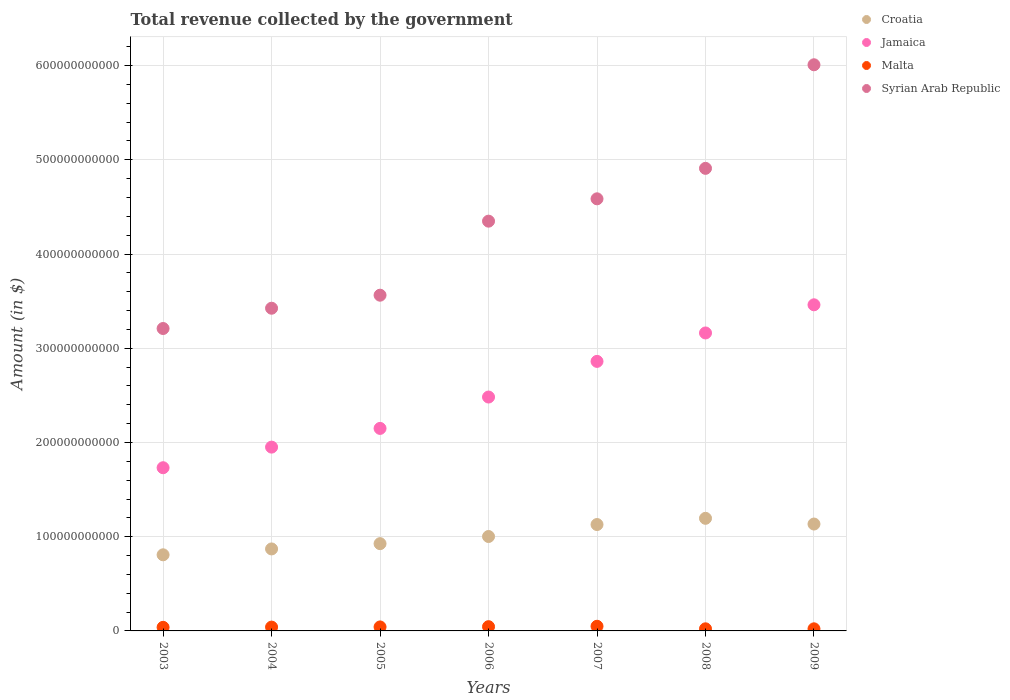How many different coloured dotlines are there?
Your answer should be compact. 4. What is the total revenue collected by the government in Syrian Arab Republic in 2005?
Keep it short and to the point. 3.56e+11. Across all years, what is the maximum total revenue collected by the government in Malta?
Your answer should be compact. 4.93e+09. Across all years, what is the minimum total revenue collected by the government in Syrian Arab Republic?
Your answer should be very brief. 3.21e+11. In which year was the total revenue collected by the government in Jamaica maximum?
Make the answer very short. 2009. In which year was the total revenue collected by the government in Croatia minimum?
Give a very brief answer. 2003. What is the total total revenue collected by the government in Malta in the graph?
Offer a terse response. 2.60e+1. What is the difference between the total revenue collected by the government in Malta in 2003 and that in 2007?
Offer a very short reply. -1.13e+09. What is the difference between the total revenue collected by the government in Syrian Arab Republic in 2003 and the total revenue collected by the government in Jamaica in 2009?
Offer a terse response. -2.52e+1. What is the average total revenue collected by the government in Syrian Arab Republic per year?
Keep it short and to the point. 4.29e+11. In the year 2005, what is the difference between the total revenue collected by the government in Croatia and total revenue collected by the government in Jamaica?
Provide a short and direct response. -1.22e+11. What is the ratio of the total revenue collected by the government in Malta in 2003 to that in 2007?
Your answer should be very brief. 0.77. Is the difference between the total revenue collected by the government in Croatia in 2007 and 2008 greater than the difference between the total revenue collected by the government in Jamaica in 2007 and 2008?
Give a very brief answer. Yes. What is the difference between the highest and the second highest total revenue collected by the government in Syrian Arab Republic?
Give a very brief answer. 1.10e+11. What is the difference between the highest and the lowest total revenue collected by the government in Syrian Arab Republic?
Provide a short and direct response. 2.80e+11. Does the total revenue collected by the government in Syrian Arab Republic monotonically increase over the years?
Your answer should be very brief. Yes. Is the total revenue collected by the government in Jamaica strictly greater than the total revenue collected by the government in Croatia over the years?
Provide a succinct answer. Yes. Is the total revenue collected by the government in Syrian Arab Republic strictly less than the total revenue collected by the government in Jamaica over the years?
Provide a succinct answer. No. How many dotlines are there?
Your answer should be compact. 4. What is the difference between two consecutive major ticks on the Y-axis?
Your response must be concise. 1.00e+11. Does the graph contain any zero values?
Your response must be concise. No. Does the graph contain grids?
Your answer should be compact. Yes. How many legend labels are there?
Your answer should be compact. 4. What is the title of the graph?
Your answer should be compact. Total revenue collected by the government. Does "Qatar" appear as one of the legend labels in the graph?
Make the answer very short. No. What is the label or title of the Y-axis?
Your response must be concise. Amount (in $). What is the Amount (in $) in Croatia in 2003?
Provide a succinct answer. 8.08e+1. What is the Amount (in $) of Jamaica in 2003?
Provide a short and direct response. 1.73e+11. What is the Amount (in $) in Malta in 2003?
Keep it short and to the point. 3.81e+09. What is the Amount (in $) in Syrian Arab Republic in 2003?
Offer a very short reply. 3.21e+11. What is the Amount (in $) of Croatia in 2004?
Ensure brevity in your answer.  8.70e+1. What is the Amount (in $) in Jamaica in 2004?
Provide a succinct answer. 1.95e+11. What is the Amount (in $) of Malta in 2004?
Provide a short and direct response. 4.05e+09. What is the Amount (in $) in Syrian Arab Republic in 2004?
Offer a very short reply. 3.42e+11. What is the Amount (in $) of Croatia in 2005?
Make the answer very short. 9.26e+1. What is the Amount (in $) in Jamaica in 2005?
Ensure brevity in your answer.  2.15e+11. What is the Amount (in $) in Malta in 2005?
Your response must be concise. 4.23e+09. What is the Amount (in $) in Syrian Arab Republic in 2005?
Offer a terse response. 3.56e+11. What is the Amount (in $) of Croatia in 2006?
Your answer should be very brief. 1.00e+11. What is the Amount (in $) of Jamaica in 2006?
Provide a short and direct response. 2.48e+11. What is the Amount (in $) in Malta in 2006?
Your answer should be compact. 4.51e+09. What is the Amount (in $) in Syrian Arab Republic in 2006?
Your response must be concise. 4.35e+11. What is the Amount (in $) in Croatia in 2007?
Keep it short and to the point. 1.13e+11. What is the Amount (in $) of Jamaica in 2007?
Give a very brief answer. 2.86e+11. What is the Amount (in $) of Malta in 2007?
Make the answer very short. 4.93e+09. What is the Amount (in $) in Syrian Arab Republic in 2007?
Provide a short and direct response. 4.59e+11. What is the Amount (in $) of Croatia in 2008?
Offer a terse response. 1.19e+11. What is the Amount (in $) of Jamaica in 2008?
Give a very brief answer. 3.16e+11. What is the Amount (in $) in Malta in 2008?
Ensure brevity in your answer.  2.24e+09. What is the Amount (in $) in Syrian Arab Republic in 2008?
Your response must be concise. 4.91e+11. What is the Amount (in $) in Croatia in 2009?
Keep it short and to the point. 1.13e+11. What is the Amount (in $) of Jamaica in 2009?
Provide a short and direct response. 3.46e+11. What is the Amount (in $) of Malta in 2009?
Your response must be concise. 2.24e+09. What is the Amount (in $) in Syrian Arab Republic in 2009?
Provide a short and direct response. 6.01e+11. Across all years, what is the maximum Amount (in $) of Croatia?
Provide a succinct answer. 1.19e+11. Across all years, what is the maximum Amount (in $) in Jamaica?
Offer a very short reply. 3.46e+11. Across all years, what is the maximum Amount (in $) of Malta?
Offer a terse response. 4.93e+09. Across all years, what is the maximum Amount (in $) of Syrian Arab Republic?
Your answer should be compact. 6.01e+11. Across all years, what is the minimum Amount (in $) in Croatia?
Keep it short and to the point. 8.08e+1. Across all years, what is the minimum Amount (in $) of Jamaica?
Ensure brevity in your answer.  1.73e+11. Across all years, what is the minimum Amount (in $) in Malta?
Your response must be concise. 2.24e+09. Across all years, what is the minimum Amount (in $) of Syrian Arab Republic?
Offer a very short reply. 3.21e+11. What is the total Amount (in $) in Croatia in the graph?
Ensure brevity in your answer.  7.06e+11. What is the total Amount (in $) in Jamaica in the graph?
Provide a succinct answer. 1.78e+12. What is the total Amount (in $) of Malta in the graph?
Your answer should be very brief. 2.60e+1. What is the total Amount (in $) in Syrian Arab Republic in the graph?
Your response must be concise. 3.00e+12. What is the difference between the Amount (in $) in Croatia in 2003 and that in 2004?
Your answer should be compact. -6.23e+09. What is the difference between the Amount (in $) in Jamaica in 2003 and that in 2004?
Your answer should be compact. -2.19e+1. What is the difference between the Amount (in $) in Malta in 2003 and that in 2004?
Make the answer very short. -2.43e+08. What is the difference between the Amount (in $) of Syrian Arab Republic in 2003 and that in 2004?
Your response must be concise. -2.15e+1. What is the difference between the Amount (in $) of Croatia in 2003 and that in 2005?
Keep it short and to the point. -1.18e+1. What is the difference between the Amount (in $) in Jamaica in 2003 and that in 2005?
Make the answer very short. -4.17e+1. What is the difference between the Amount (in $) in Malta in 2003 and that in 2005?
Offer a very short reply. -4.25e+08. What is the difference between the Amount (in $) in Syrian Arab Republic in 2003 and that in 2005?
Offer a very short reply. -3.54e+1. What is the difference between the Amount (in $) in Croatia in 2003 and that in 2006?
Ensure brevity in your answer.  -1.94e+1. What is the difference between the Amount (in $) in Jamaica in 2003 and that in 2006?
Offer a very short reply. -7.50e+1. What is the difference between the Amount (in $) of Malta in 2003 and that in 2006?
Make the answer very short. -7.00e+08. What is the difference between the Amount (in $) in Syrian Arab Republic in 2003 and that in 2006?
Provide a short and direct response. -1.14e+11. What is the difference between the Amount (in $) in Croatia in 2003 and that in 2007?
Offer a terse response. -3.21e+1. What is the difference between the Amount (in $) in Jamaica in 2003 and that in 2007?
Ensure brevity in your answer.  -1.13e+11. What is the difference between the Amount (in $) in Malta in 2003 and that in 2007?
Your response must be concise. -1.13e+09. What is the difference between the Amount (in $) of Syrian Arab Republic in 2003 and that in 2007?
Your answer should be very brief. -1.38e+11. What is the difference between the Amount (in $) of Croatia in 2003 and that in 2008?
Provide a succinct answer. -3.87e+1. What is the difference between the Amount (in $) in Jamaica in 2003 and that in 2008?
Provide a short and direct response. -1.43e+11. What is the difference between the Amount (in $) in Malta in 2003 and that in 2008?
Your answer should be very brief. 1.57e+09. What is the difference between the Amount (in $) of Syrian Arab Republic in 2003 and that in 2008?
Make the answer very short. -1.70e+11. What is the difference between the Amount (in $) in Croatia in 2003 and that in 2009?
Make the answer very short. -3.27e+1. What is the difference between the Amount (in $) in Jamaica in 2003 and that in 2009?
Offer a terse response. -1.73e+11. What is the difference between the Amount (in $) of Malta in 2003 and that in 2009?
Ensure brevity in your answer.  1.57e+09. What is the difference between the Amount (in $) in Syrian Arab Republic in 2003 and that in 2009?
Give a very brief answer. -2.80e+11. What is the difference between the Amount (in $) in Croatia in 2004 and that in 2005?
Give a very brief answer. -5.61e+09. What is the difference between the Amount (in $) in Jamaica in 2004 and that in 2005?
Give a very brief answer. -1.99e+1. What is the difference between the Amount (in $) of Malta in 2004 and that in 2005?
Your answer should be compact. -1.83e+08. What is the difference between the Amount (in $) in Syrian Arab Republic in 2004 and that in 2005?
Your answer should be compact. -1.38e+1. What is the difference between the Amount (in $) of Croatia in 2004 and that in 2006?
Keep it short and to the point. -1.32e+1. What is the difference between the Amount (in $) of Jamaica in 2004 and that in 2006?
Ensure brevity in your answer.  -5.32e+1. What is the difference between the Amount (in $) of Malta in 2004 and that in 2006?
Provide a succinct answer. -4.58e+08. What is the difference between the Amount (in $) in Syrian Arab Republic in 2004 and that in 2006?
Your answer should be very brief. -9.24e+1. What is the difference between the Amount (in $) of Croatia in 2004 and that in 2007?
Make the answer very short. -2.59e+1. What is the difference between the Amount (in $) of Jamaica in 2004 and that in 2007?
Make the answer very short. -9.10e+1. What is the difference between the Amount (in $) of Malta in 2004 and that in 2007?
Provide a succinct answer. -8.84e+08. What is the difference between the Amount (in $) in Syrian Arab Republic in 2004 and that in 2007?
Provide a succinct answer. -1.16e+11. What is the difference between the Amount (in $) of Croatia in 2004 and that in 2008?
Keep it short and to the point. -3.25e+1. What is the difference between the Amount (in $) of Jamaica in 2004 and that in 2008?
Your answer should be compact. -1.21e+11. What is the difference between the Amount (in $) in Malta in 2004 and that in 2008?
Offer a very short reply. 1.81e+09. What is the difference between the Amount (in $) of Syrian Arab Republic in 2004 and that in 2008?
Give a very brief answer. -1.48e+11. What is the difference between the Amount (in $) of Croatia in 2004 and that in 2009?
Your response must be concise. -2.64e+1. What is the difference between the Amount (in $) of Jamaica in 2004 and that in 2009?
Your response must be concise. -1.51e+11. What is the difference between the Amount (in $) in Malta in 2004 and that in 2009?
Keep it short and to the point. 1.81e+09. What is the difference between the Amount (in $) of Syrian Arab Republic in 2004 and that in 2009?
Offer a very short reply. -2.58e+11. What is the difference between the Amount (in $) of Croatia in 2005 and that in 2006?
Keep it short and to the point. -7.58e+09. What is the difference between the Amount (in $) of Jamaica in 2005 and that in 2006?
Give a very brief answer. -3.33e+1. What is the difference between the Amount (in $) of Malta in 2005 and that in 2006?
Give a very brief answer. -2.75e+08. What is the difference between the Amount (in $) of Syrian Arab Republic in 2005 and that in 2006?
Your answer should be very brief. -7.86e+1. What is the difference between the Amount (in $) of Croatia in 2005 and that in 2007?
Offer a terse response. -2.03e+1. What is the difference between the Amount (in $) of Jamaica in 2005 and that in 2007?
Keep it short and to the point. -7.11e+1. What is the difference between the Amount (in $) in Malta in 2005 and that in 2007?
Your answer should be compact. -7.01e+08. What is the difference between the Amount (in $) in Syrian Arab Republic in 2005 and that in 2007?
Ensure brevity in your answer.  -1.02e+11. What is the difference between the Amount (in $) of Croatia in 2005 and that in 2008?
Give a very brief answer. -2.69e+1. What is the difference between the Amount (in $) in Jamaica in 2005 and that in 2008?
Make the answer very short. -1.01e+11. What is the difference between the Amount (in $) of Malta in 2005 and that in 2008?
Your answer should be compact. 1.99e+09. What is the difference between the Amount (in $) of Syrian Arab Republic in 2005 and that in 2008?
Offer a terse response. -1.35e+11. What is the difference between the Amount (in $) of Croatia in 2005 and that in 2009?
Ensure brevity in your answer.  -2.08e+1. What is the difference between the Amount (in $) of Jamaica in 2005 and that in 2009?
Give a very brief answer. -1.31e+11. What is the difference between the Amount (in $) in Malta in 2005 and that in 2009?
Provide a succinct answer. 2.00e+09. What is the difference between the Amount (in $) of Syrian Arab Republic in 2005 and that in 2009?
Your answer should be compact. -2.45e+11. What is the difference between the Amount (in $) in Croatia in 2006 and that in 2007?
Make the answer very short. -1.27e+1. What is the difference between the Amount (in $) in Jamaica in 2006 and that in 2007?
Give a very brief answer. -3.78e+1. What is the difference between the Amount (in $) in Malta in 2006 and that in 2007?
Make the answer very short. -4.26e+08. What is the difference between the Amount (in $) of Syrian Arab Republic in 2006 and that in 2007?
Provide a succinct answer. -2.37e+1. What is the difference between the Amount (in $) of Croatia in 2006 and that in 2008?
Your answer should be very brief. -1.93e+1. What is the difference between the Amount (in $) in Jamaica in 2006 and that in 2008?
Offer a very short reply. -6.80e+1. What is the difference between the Amount (in $) of Malta in 2006 and that in 2008?
Ensure brevity in your answer.  2.27e+09. What is the difference between the Amount (in $) in Syrian Arab Republic in 2006 and that in 2008?
Offer a terse response. -5.60e+1. What is the difference between the Amount (in $) of Croatia in 2006 and that in 2009?
Provide a succinct answer. -1.32e+1. What is the difference between the Amount (in $) in Jamaica in 2006 and that in 2009?
Your response must be concise. -9.79e+1. What is the difference between the Amount (in $) of Malta in 2006 and that in 2009?
Make the answer very short. 2.27e+09. What is the difference between the Amount (in $) in Syrian Arab Republic in 2006 and that in 2009?
Your answer should be very brief. -1.66e+11. What is the difference between the Amount (in $) of Croatia in 2007 and that in 2008?
Your answer should be very brief. -6.59e+09. What is the difference between the Amount (in $) in Jamaica in 2007 and that in 2008?
Offer a very short reply. -3.02e+1. What is the difference between the Amount (in $) of Malta in 2007 and that in 2008?
Your answer should be compact. 2.69e+09. What is the difference between the Amount (in $) of Syrian Arab Republic in 2007 and that in 2008?
Provide a succinct answer. -3.23e+1. What is the difference between the Amount (in $) in Croatia in 2007 and that in 2009?
Ensure brevity in your answer.  -5.30e+08. What is the difference between the Amount (in $) in Jamaica in 2007 and that in 2009?
Ensure brevity in your answer.  -6.01e+1. What is the difference between the Amount (in $) of Malta in 2007 and that in 2009?
Make the answer very short. 2.70e+09. What is the difference between the Amount (in $) of Syrian Arab Republic in 2007 and that in 2009?
Your answer should be very brief. -1.42e+11. What is the difference between the Amount (in $) of Croatia in 2008 and that in 2009?
Provide a short and direct response. 6.06e+09. What is the difference between the Amount (in $) in Jamaica in 2008 and that in 2009?
Your answer should be compact. -2.99e+1. What is the difference between the Amount (in $) in Malta in 2008 and that in 2009?
Your answer should be compact. 6.17e+06. What is the difference between the Amount (in $) in Syrian Arab Republic in 2008 and that in 2009?
Your answer should be very brief. -1.10e+11. What is the difference between the Amount (in $) of Croatia in 2003 and the Amount (in $) of Jamaica in 2004?
Give a very brief answer. -1.14e+11. What is the difference between the Amount (in $) in Croatia in 2003 and the Amount (in $) in Malta in 2004?
Your answer should be very brief. 7.67e+1. What is the difference between the Amount (in $) in Croatia in 2003 and the Amount (in $) in Syrian Arab Republic in 2004?
Make the answer very short. -2.62e+11. What is the difference between the Amount (in $) in Jamaica in 2003 and the Amount (in $) in Malta in 2004?
Ensure brevity in your answer.  1.69e+11. What is the difference between the Amount (in $) in Jamaica in 2003 and the Amount (in $) in Syrian Arab Republic in 2004?
Offer a very short reply. -1.69e+11. What is the difference between the Amount (in $) in Malta in 2003 and the Amount (in $) in Syrian Arab Republic in 2004?
Provide a short and direct response. -3.39e+11. What is the difference between the Amount (in $) of Croatia in 2003 and the Amount (in $) of Jamaica in 2005?
Your answer should be very brief. -1.34e+11. What is the difference between the Amount (in $) in Croatia in 2003 and the Amount (in $) in Malta in 2005?
Keep it short and to the point. 7.65e+1. What is the difference between the Amount (in $) of Croatia in 2003 and the Amount (in $) of Syrian Arab Republic in 2005?
Your response must be concise. -2.76e+11. What is the difference between the Amount (in $) of Jamaica in 2003 and the Amount (in $) of Malta in 2005?
Provide a short and direct response. 1.69e+11. What is the difference between the Amount (in $) of Jamaica in 2003 and the Amount (in $) of Syrian Arab Republic in 2005?
Give a very brief answer. -1.83e+11. What is the difference between the Amount (in $) of Malta in 2003 and the Amount (in $) of Syrian Arab Republic in 2005?
Your response must be concise. -3.52e+11. What is the difference between the Amount (in $) of Croatia in 2003 and the Amount (in $) of Jamaica in 2006?
Provide a short and direct response. -1.67e+11. What is the difference between the Amount (in $) in Croatia in 2003 and the Amount (in $) in Malta in 2006?
Your response must be concise. 7.63e+1. What is the difference between the Amount (in $) in Croatia in 2003 and the Amount (in $) in Syrian Arab Republic in 2006?
Offer a terse response. -3.54e+11. What is the difference between the Amount (in $) of Jamaica in 2003 and the Amount (in $) of Malta in 2006?
Make the answer very short. 1.69e+11. What is the difference between the Amount (in $) in Jamaica in 2003 and the Amount (in $) in Syrian Arab Republic in 2006?
Your answer should be compact. -2.62e+11. What is the difference between the Amount (in $) of Malta in 2003 and the Amount (in $) of Syrian Arab Republic in 2006?
Offer a very short reply. -4.31e+11. What is the difference between the Amount (in $) of Croatia in 2003 and the Amount (in $) of Jamaica in 2007?
Offer a very short reply. -2.05e+11. What is the difference between the Amount (in $) in Croatia in 2003 and the Amount (in $) in Malta in 2007?
Your answer should be compact. 7.58e+1. What is the difference between the Amount (in $) of Croatia in 2003 and the Amount (in $) of Syrian Arab Republic in 2007?
Offer a very short reply. -3.78e+11. What is the difference between the Amount (in $) in Jamaica in 2003 and the Amount (in $) in Malta in 2007?
Offer a terse response. 1.68e+11. What is the difference between the Amount (in $) of Jamaica in 2003 and the Amount (in $) of Syrian Arab Republic in 2007?
Ensure brevity in your answer.  -2.85e+11. What is the difference between the Amount (in $) of Malta in 2003 and the Amount (in $) of Syrian Arab Republic in 2007?
Keep it short and to the point. -4.55e+11. What is the difference between the Amount (in $) of Croatia in 2003 and the Amount (in $) of Jamaica in 2008?
Your answer should be compact. -2.35e+11. What is the difference between the Amount (in $) in Croatia in 2003 and the Amount (in $) in Malta in 2008?
Your answer should be very brief. 7.85e+1. What is the difference between the Amount (in $) of Croatia in 2003 and the Amount (in $) of Syrian Arab Republic in 2008?
Ensure brevity in your answer.  -4.10e+11. What is the difference between the Amount (in $) of Jamaica in 2003 and the Amount (in $) of Malta in 2008?
Your answer should be very brief. 1.71e+11. What is the difference between the Amount (in $) in Jamaica in 2003 and the Amount (in $) in Syrian Arab Republic in 2008?
Your answer should be compact. -3.18e+11. What is the difference between the Amount (in $) in Malta in 2003 and the Amount (in $) in Syrian Arab Republic in 2008?
Ensure brevity in your answer.  -4.87e+11. What is the difference between the Amount (in $) in Croatia in 2003 and the Amount (in $) in Jamaica in 2009?
Provide a succinct answer. -2.65e+11. What is the difference between the Amount (in $) of Croatia in 2003 and the Amount (in $) of Malta in 2009?
Offer a very short reply. 7.85e+1. What is the difference between the Amount (in $) of Croatia in 2003 and the Amount (in $) of Syrian Arab Republic in 2009?
Keep it short and to the point. -5.20e+11. What is the difference between the Amount (in $) in Jamaica in 2003 and the Amount (in $) in Malta in 2009?
Your answer should be compact. 1.71e+11. What is the difference between the Amount (in $) in Jamaica in 2003 and the Amount (in $) in Syrian Arab Republic in 2009?
Your response must be concise. -4.28e+11. What is the difference between the Amount (in $) in Malta in 2003 and the Amount (in $) in Syrian Arab Republic in 2009?
Your answer should be compact. -5.97e+11. What is the difference between the Amount (in $) of Croatia in 2004 and the Amount (in $) of Jamaica in 2005?
Keep it short and to the point. -1.28e+11. What is the difference between the Amount (in $) in Croatia in 2004 and the Amount (in $) in Malta in 2005?
Give a very brief answer. 8.28e+1. What is the difference between the Amount (in $) of Croatia in 2004 and the Amount (in $) of Syrian Arab Republic in 2005?
Offer a terse response. -2.69e+11. What is the difference between the Amount (in $) in Jamaica in 2004 and the Amount (in $) in Malta in 2005?
Ensure brevity in your answer.  1.91e+11. What is the difference between the Amount (in $) in Jamaica in 2004 and the Amount (in $) in Syrian Arab Republic in 2005?
Provide a short and direct response. -1.61e+11. What is the difference between the Amount (in $) of Malta in 2004 and the Amount (in $) of Syrian Arab Republic in 2005?
Your answer should be compact. -3.52e+11. What is the difference between the Amount (in $) of Croatia in 2004 and the Amount (in $) of Jamaica in 2006?
Your answer should be very brief. -1.61e+11. What is the difference between the Amount (in $) in Croatia in 2004 and the Amount (in $) in Malta in 2006?
Make the answer very short. 8.25e+1. What is the difference between the Amount (in $) of Croatia in 2004 and the Amount (in $) of Syrian Arab Republic in 2006?
Make the answer very short. -3.48e+11. What is the difference between the Amount (in $) of Jamaica in 2004 and the Amount (in $) of Malta in 2006?
Your response must be concise. 1.91e+11. What is the difference between the Amount (in $) of Jamaica in 2004 and the Amount (in $) of Syrian Arab Republic in 2006?
Keep it short and to the point. -2.40e+11. What is the difference between the Amount (in $) in Malta in 2004 and the Amount (in $) in Syrian Arab Republic in 2006?
Provide a succinct answer. -4.31e+11. What is the difference between the Amount (in $) of Croatia in 2004 and the Amount (in $) of Jamaica in 2007?
Your answer should be compact. -1.99e+11. What is the difference between the Amount (in $) of Croatia in 2004 and the Amount (in $) of Malta in 2007?
Provide a succinct answer. 8.21e+1. What is the difference between the Amount (in $) of Croatia in 2004 and the Amount (in $) of Syrian Arab Republic in 2007?
Your response must be concise. -3.72e+11. What is the difference between the Amount (in $) in Jamaica in 2004 and the Amount (in $) in Malta in 2007?
Keep it short and to the point. 1.90e+11. What is the difference between the Amount (in $) of Jamaica in 2004 and the Amount (in $) of Syrian Arab Republic in 2007?
Offer a terse response. -2.64e+11. What is the difference between the Amount (in $) of Malta in 2004 and the Amount (in $) of Syrian Arab Republic in 2007?
Give a very brief answer. -4.55e+11. What is the difference between the Amount (in $) of Croatia in 2004 and the Amount (in $) of Jamaica in 2008?
Provide a short and direct response. -2.29e+11. What is the difference between the Amount (in $) of Croatia in 2004 and the Amount (in $) of Malta in 2008?
Ensure brevity in your answer.  8.48e+1. What is the difference between the Amount (in $) in Croatia in 2004 and the Amount (in $) in Syrian Arab Republic in 2008?
Offer a very short reply. -4.04e+11. What is the difference between the Amount (in $) of Jamaica in 2004 and the Amount (in $) of Malta in 2008?
Keep it short and to the point. 1.93e+11. What is the difference between the Amount (in $) in Jamaica in 2004 and the Amount (in $) in Syrian Arab Republic in 2008?
Make the answer very short. -2.96e+11. What is the difference between the Amount (in $) of Malta in 2004 and the Amount (in $) of Syrian Arab Republic in 2008?
Provide a short and direct response. -4.87e+11. What is the difference between the Amount (in $) in Croatia in 2004 and the Amount (in $) in Jamaica in 2009?
Provide a short and direct response. -2.59e+11. What is the difference between the Amount (in $) in Croatia in 2004 and the Amount (in $) in Malta in 2009?
Your answer should be very brief. 8.48e+1. What is the difference between the Amount (in $) of Croatia in 2004 and the Amount (in $) of Syrian Arab Republic in 2009?
Provide a succinct answer. -5.14e+11. What is the difference between the Amount (in $) in Jamaica in 2004 and the Amount (in $) in Malta in 2009?
Your answer should be very brief. 1.93e+11. What is the difference between the Amount (in $) of Jamaica in 2004 and the Amount (in $) of Syrian Arab Republic in 2009?
Ensure brevity in your answer.  -4.06e+11. What is the difference between the Amount (in $) in Malta in 2004 and the Amount (in $) in Syrian Arab Republic in 2009?
Make the answer very short. -5.97e+11. What is the difference between the Amount (in $) in Croatia in 2005 and the Amount (in $) in Jamaica in 2006?
Provide a succinct answer. -1.56e+11. What is the difference between the Amount (in $) in Croatia in 2005 and the Amount (in $) in Malta in 2006?
Offer a terse response. 8.81e+1. What is the difference between the Amount (in $) of Croatia in 2005 and the Amount (in $) of Syrian Arab Republic in 2006?
Provide a short and direct response. -3.42e+11. What is the difference between the Amount (in $) in Jamaica in 2005 and the Amount (in $) in Malta in 2006?
Offer a very short reply. 2.10e+11. What is the difference between the Amount (in $) in Jamaica in 2005 and the Amount (in $) in Syrian Arab Republic in 2006?
Give a very brief answer. -2.20e+11. What is the difference between the Amount (in $) in Malta in 2005 and the Amount (in $) in Syrian Arab Republic in 2006?
Make the answer very short. -4.31e+11. What is the difference between the Amount (in $) in Croatia in 2005 and the Amount (in $) in Jamaica in 2007?
Your response must be concise. -1.93e+11. What is the difference between the Amount (in $) in Croatia in 2005 and the Amount (in $) in Malta in 2007?
Make the answer very short. 8.77e+1. What is the difference between the Amount (in $) of Croatia in 2005 and the Amount (in $) of Syrian Arab Republic in 2007?
Offer a terse response. -3.66e+11. What is the difference between the Amount (in $) in Jamaica in 2005 and the Amount (in $) in Malta in 2007?
Your answer should be very brief. 2.10e+11. What is the difference between the Amount (in $) of Jamaica in 2005 and the Amount (in $) of Syrian Arab Republic in 2007?
Provide a succinct answer. -2.44e+11. What is the difference between the Amount (in $) in Malta in 2005 and the Amount (in $) in Syrian Arab Republic in 2007?
Provide a succinct answer. -4.54e+11. What is the difference between the Amount (in $) in Croatia in 2005 and the Amount (in $) in Jamaica in 2008?
Provide a succinct answer. -2.24e+11. What is the difference between the Amount (in $) in Croatia in 2005 and the Amount (in $) in Malta in 2008?
Offer a very short reply. 9.04e+1. What is the difference between the Amount (in $) of Croatia in 2005 and the Amount (in $) of Syrian Arab Republic in 2008?
Your response must be concise. -3.98e+11. What is the difference between the Amount (in $) in Jamaica in 2005 and the Amount (in $) in Malta in 2008?
Your answer should be compact. 2.13e+11. What is the difference between the Amount (in $) in Jamaica in 2005 and the Amount (in $) in Syrian Arab Republic in 2008?
Offer a very short reply. -2.76e+11. What is the difference between the Amount (in $) in Malta in 2005 and the Amount (in $) in Syrian Arab Republic in 2008?
Keep it short and to the point. -4.87e+11. What is the difference between the Amount (in $) in Croatia in 2005 and the Amount (in $) in Jamaica in 2009?
Provide a short and direct response. -2.53e+11. What is the difference between the Amount (in $) of Croatia in 2005 and the Amount (in $) of Malta in 2009?
Provide a succinct answer. 9.04e+1. What is the difference between the Amount (in $) of Croatia in 2005 and the Amount (in $) of Syrian Arab Republic in 2009?
Provide a short and direct response. -5.08e+11. What is the difference between the Amount (in $) in Jamaica in 2005 and the Amount (in $) in Malta in 2009?
Offer a very short reply. 2.13e+11. What is the difference between the Amount (in $) of Jamaica in 2005 and the Amount (in $) of Syrian Arab Republic in 2009?
Offer a terse response. -3.86e+11. What is the difference between the Amount (in $) in Malta in 2005 and the Amount (in $) in Syrian Arab Republic in 2009?
Make the answer very short. -5.97e+11. What is the difference between the Amount (in $) of Croatia in 2006 and the Amount (in $) of Jamaica in 2007?
Your answer should be compact. -1.86e+11. What is the difference between the Amount (in $) of Croatia in 2006 and the Amount (in $) of Malta in 2007?
Offer a very short reply. 9.53e+1. What is the difference between the Amount (in $) of Croatia in 2006 and the Amount (in $) of Syrian Arab Republic in 2007?
Make the answer very short. -3.58e+11. What is the difference between the Amount (in $) in Jamaica in 2006 and the Amount (in $) in Malta in 2007?
Ensure brevity in your answer.  2.43e+11. What is the difference between the Amount (in $) in Jamaica in 2006 and the Amount (in $) in Syrian Arab Republic in 2007?
Keep it short and to the point. -2.10e+11. What is the difference between the Amount (in $) of Malta in 2006 and the Amount (in $) of Syrian Arab Republic in 2007?
Make the answer very short. -4.54e+11. What is the difference between the Amount (in $) in Croatia in 2006 and the Amount (in $) in Jamaica in 2008?
Give a very brief answer. -2.16e+11. What is the difference between the Amount (in $) in Croatia in 2006 and the Amount (in $) in Malta in 2008?
Keep it short and to the point. 9.80e+1. What is the difference between the Amount (in $) in Croatia in 2006 and the Amount (in $) in Syrian Arab Republic in 2008?
Provide a succinct answer. -3.91e+11. What is the difference between the Amount (in $) in Jamaica in 2006 and the Amount (in $) in Malta in 2008?
Your answer should be very brief. 2.46e+11. What is the difference between the Amount (in $) of Jamaica in 2006 and the Amount (in $) of Syrian Arab Republic in 2008?
Keep it short and to the point. -2.43e+11. What is the difference between the Amount (in $) of Malta in 2006 and the Amount (in $) of Syrian Arab Republic in 2008?
Ensure brevity in your answer.  -4.86e+11. What is the difference between the Amount (in $) of Croatia in 2006 and the Amount (in $) of Jamaica in 2009?
Offer a terse response. -2.46e+11. What is the difference between the Amount (in $) in Croatia in 2006 and the Amount (in $) in Malta in 2009?
Your response must be concise. 9.80e+1. What is the difference between the Amount (in $) in Croatia in 2006 and the Amount (in $) in Syrian Arab Republic in 2009?
Make the answer very short. -5.01e+11. What is the difference between the Amount (in $) in Jamaica in 2006 and the Amount (in $) in Malta in 2009?
Provide a short and direct response. 2.46e+11. What is the difference between the Amount (in $) of Jamaica in 2006 and the Amount (in $) of Syrian Arab Republic in 2009?
Offer a very short reply. -3.53e+11. What is the difference between the Amount (in $) of Malta in 2006 and the Amount (in $) of Syrian Arab Republic in 2009?
Make the answer very short. -5.96e+11. What is the difference between the Amount (in $) of Croatia in 2007 and the Amount (in $) of Jamaica in 2008?
Ensure brevity in your answer.  -2.03e+11. What is the difference between the Amount (in $) of Croatia in 2007 and the Amount (in $) of Malta in 2008?
Make the answer very short. 1.11e+11. What is the difference between the Amount (in $) of Croatia in 2007 and the Amount (in $) of Syrian Arab Republic in 2008?
Ensure brevity in your answer.  -3.78e+11. What is the difference between the Amount (in $) in Jamaica in 2007 and the Amount (in $) in Malta in 2008?
Provide a short and direct response. 2.84e+11. What is the difference between the Amount (in $) of Jamaica in 2007 and the Amount (in $) of Syrian Arab Republic in 2008?
Your answer should be compact. -2.05e+11. What is the difference between the Amount (in $) in Malta in 2007 and the Amount (in $) in Syrian Arab Republic in 2008?
Your answer should be very brief. -4.86e+11. What is the difference between the Amount (in $) in Croatia in 2007 and the Amount (in $) in Jamaica in 2009?
Offer a very short reply. -2.33e+11. What is the difference between the Amount (in $) of Croatia in 2007 and the Amount (in $) of Malta in 2009?
Provide a short and direct response. 1.11e+11. What is the difference between the Amount (in $) in Croatia in 2007 and the Amount (in $) in Syrian Arab Republic in 2009?
Your response must be concise. -4.88e+11. What is the difference between the Amount (in $) in Jamaica in 2007 and the Amount (in $) in Malta in 2009?
Your response must be concise. 2.84e+11. What is the difference between the Amount (in $) of Jamaica in 2007 and the Amount (in $) of Syrian Arab Republic in 2009?
Offer a terse response. -3.15e+11. What is the difference between the Amount (in $) of Malta in 2007 and the Amount (in $) of Syrian Arab Republic in 2009?
Your response must be concise. -5.96e+11. What is the difference between the Amount (in $) of Croatia in 2008 and the Amount (in $) of Jamaica in 2009?
Your answer should be compact. -2.27e+11. What is the difference between the Amount (in $) in Croatia in 2008 and the Amount (in $) in Malta in 2009?
Provide a short and direct response. 1.17e+11. What is the difference between the Amount (in $) in Croatia in 2008 and the Amount (in $) in Syrian Arab Republic in 2009?
Provide a succinct answer. -4.81e+11. What is the difference between the Amount (in $) of Jamaica in 2008 and the Amount (in $) of Malta in 2009?
Make the answer very short. 3.14e+11. What is the difference between the Amount (in $) in Jamaica in 2008 and the Amount (in $) in Syrian Arab Republic in 2009?
Give a very brief answer. -2.85e+11. What is the difference between the Amount (in $) of Malta in 2008 and the Amount (in $) of Syrian Arab Republic in 2009?
Provide a succinct answer. -5.99e+11. What is the average Amount (in $) in Croatia per year?
Your answer should be very brief. 1.01e+11. What is the average Amount (in $) in Jamaica per year?
Your answer should be compact. 2.54e+11. What is the average Amount (in $) in Malta per year?
Make the answer very short. 3.72e+09. What is the average Amount (in $) of Syrian Arab Republic per year?
Your response must be concise. 4.29e+11. In the year 2003, what is the difference between the Amount (in $) of Croatia and Amount (in $) of Jamaica?
Provide a short and direct response. -9.24e+1. In the year 2003, what is the difference between the Amount (in $) in Croatia and Amount (in $) in Malta?
Offer a terse response. 7.70e+1. In the year 2003, what is the difference between the Amount (in $) in Croatia and Amount (in $) in Syrian Arab Republic?
Keep it short and to the point. -2.40e+11. In the year 2003, what is the difference between the Amount (in $) in Jamaica and Amount (in $) in Malta?
Provide a short and direct response. 1.69e+11. In the year 2003, what is the difference between the Amount (in $) of Jamaica and Amount (in $) of Syrian Arab Republic?
Your response must be concise. -1.48e+11. In the year 2003, what is the difference between the Amount (in $) of Malta and Amount (in $) of Syrian Arab Republic?
Keep it short and to the point. -3.17e+11. In the year 2004, what is the difference between the Amount (in $) in Croatia and Amount (in $) in Jamaica?
Your answer should be very brief. -1.08e+11. In the year 2004, what is the difference between the Amount (in $) in Croatia and Amount (in $) in Malta?
Provide a short and direct response. 8.30e+1. In the year 2004, what is the difference between the Amount (in $) in Croatia and Amount (in $) in Syrian Arab Republic?
Provide a succinct answer. -2.55e+11. In the year 2004, what is the difference between the Amount (in $) in Jamaica and Amount (in $) in Malta?
Ensure brevity in your answer.  1.91e+11. In the year 2004, what is the difference between the Amount (in $) in Jamaica and Amount (in $) in Syrian Arab Republic?
Provide a short and direct response. -1.47e+11. In the year 2004, what is the difference between the Amount (in $) in Malta and Amount (in $) in Syrian Arab Republic?
Offer a terse response. -3.38e+11. In the year 2005, what is the difference between the Amount (in $) of Croatia and Amount (in $) of Jamaica?
Offer a terse response. -1.22e+11. In the year 2005, what is the difference between the Amount (in $) of Croatia and Amount (in $) of Malta?
Your answer should be compact. 8.84e+1. In the year 2005, what is the difference between the Amount (in $) in Croatia and Amount (in $) in Syrian Arab Republic?
Offer a very short reply. -2.64e+11. In the year 2005, what is the difference between the Amount (in $) of Jamaica and Amount (in $) of Malta?
Provide a short and direct response. 2.11e+11. In the year 2005, what is the difference between the Amount (in $) of Jamaica and Amount (in $) of Syrian Arab Republic?
Provide a succinct answer. -1.41e+11. In the year 2005, what is the difference between the Amount (in $) of Malta and Amount (in $) of Syrian Arab Republic?
Ensure brevity in your answer.  -3.52e+11. In the year 2006, what is the difference between the Amount (in $) in Croatia and Amount (in $) in Jamaica?
Keep it short and to the point. -1.48e+11. In the year 2006, what is the difference between the Amount (in $) of Croatia and Amount (in $) of Malta?
Offer a terse response. 9.57e+1. In the year 2006, what is the difference between the Amount (in $) of Croatia and Amount (in $) of Syrian Arab Republic?
Provide a short and direct response. -3.35e+11. In the year 2006, what is the difference between the Amount (in $) in Jamaica and Amount (in $) in Malta?
Offer a terse response. 2.44e+11. In the year 2006, what is the difference between the Amount (in $) of Jamaica and Amount (in $) of Syrian Arab Republic?
Your response must be concise. -1.87e+11. In the year 2006, what is the difference between the Amount (in $) in Malta and Amount (in $) in Syrian Arab Republic?
Provide a short and direct response. -4.30e+11. In the year 2007, what is the difference between the Amount (in $) of Croatia and Amount (in $) of Jamaica?
Your response must be concise. -1.73e+11. In the year 2007, what is the difference between the Amount (in $) in Croatia and Amount (in $) in Malta?
Make the answer very short. 1.08e+11. In the year 2007, what is the difference between the Amount (in $) in Croatia and Amount (in $) in Syrian Arab Republic?
Ensure brevity in your answer.  -3.46e+11. In the year 2007, what is the difference between the Amount (in $) of Jamaica and Amount (in $) of Malta?
Keep it short and to the point. 2.81e+11. In the year 2007, what is the difference between the Amount (in $) of Jamaica and Amount (in $) of Syrian Arab Republic?
Give a very brief answer. -1.73e+11. In the year 2007, what is the difference between the Amount (in $) of Malta and Amount (in $) of Syrian Arab Republic?
Offer a very short reply. -4.54e+11. In the year 2008, what is the difference between the Amount (in $) of Croatia and Amount (in $) of Jamaica?
Give a very brief answer. -1.97e+11. In the year 2008, what is the difference between the Amount (in $) in Croatia and Amount (in $) in Malta?
Your answer should be very brief. 1.17e+11. In the year 2008, what is the difference between the Amount (in $) of Croatia and Amount (in $) of Syrian Arab Republic?
Provide a succinct answer. -3.71e+11. In the year 2008, what is the difference between the Amount (in $) in Jamaica and Amount (in $) in Malta?
Your response must be concise. 3.14e+11. In the year 2008, what is the difference between the Amount (in $) of Jamaica and Amount (in $) of Syrian Arab Republic?
Offer a terse response. -1.75e+11. In the year 2008, what is the difference between the Amount (in $) in Malta and Amount (in $) in Syrian Arab Republic?
Provide a succinct answer. -4.89e+11. In the year 2009, what is the difference between the Amount (in $) of Croatia and Amount (in $) of Jamaica?
Your response must be concise. -2.33e+11. In the year 2009, what is the difference between the Amount (in $) of Croatia and Amount (in $) of Malta?
Give a very brief answer. 1.11e+11. In the year 2009, what is the difference between the Amount (in $) of Croatia and Amount (in $) of Syrian Arab Republic?
Provide a short and direct response. -4.87e+11. In the year 2009, what is the difference between the Amount (in $) of Jamaica and Amount (in $) of Malta?
Offer a very short reply. 3.44e+11. In the year 2009, what is the difference between the Amount (in $) in Jamaica and Amount (in $) in Syrian Arab Republic?
Your answer should be compact. -2.55e+11. In the year 2009, what is the difference between the Amount (in $) in Malta and Amount (in $) in Syrian Arab Republic?
Keep it short and to the point. -5.99e+11. What is the ratio of the Amount (in $) of Croatia in 2003 to that in 2004?
Your answer should be compact. 0.93. What is the ratio of the Amount (in $) in Jamaica in 2003 to that in 2004?
Ensure brevity in your answer.  0.89. What is the ratio of the Amount (in $) of Malta in 2003 to that in 2004?
Offer a very short reply. 0.94. What is the ratio of the Amount (in $) of Syrian Arab Republic in 2003 to that in 2004?
Your answer should be compact. 0.94. What is the ratio of the Amount (in $) of Croatia in 2003 to that in 2005?
Offer a terse response. 0.87. What is the ratio of the Amount (in $) of Jamaica in 2003 to that in 2005?
Offer a terse response. 0.81. What is the ratio of the Amount (in $) of Malta in 2003 to that in 2005?
Offer a terse response. 0.9. What is the ratio of the Amount (in $) in Syrian Arab Republic in 2003 to that in 2005?
Provide a short and direct response. 0.9. What is the ratio of the Amount (in $) of Croatia in 2003 to that in 2006?
Keep it short and to the point. 0.81. What is the ratio of the Amount (in $) in Jamaica in 2003 to that in 2006?
Keep it short and to the point. 0.7. What is the ratio of the Amount (in $) in Malta in 2003 to that in 2006?
Offer a terse response. 0.84. What is the ratio of the Amount (in $) of Syrian Arab Republic in 2003 to that in 2006?
Keep it short and to the point. 0.74. What is the ratio of the Amount (in $) in Croatia in 2003 to that in 2007?
Your response must be concise. 0.72. What is the ratio of the Amount (in $) in Jamaica in 2003 to that in 2007?
Provide a short and direct response. 0.61. What is the ratio of the Amount (in $) in Malta in 2003 to that in 2007?
Give a very brief answer. 0.77. What is the ratio of the Amount (in $) of Syrian Arab Republic in 2003 to that in 2007?
Keep it short and to the point. 0.7. What is the ratio of the Amount (in $) of Croatia in 2003 to that in 2008?
Provide a short and direct response. 0.68. What is the ratio of the Amount (in $) of Jamaica in 2003 to that in 2008?
Provide a short and direct response. 0.55. What is the ratio of the Amount (in $) in Malta in 2003 to that in 2008?
Provide a short and direct response. 1.7. What is the ratio of the Amount (in $) in Syrian Arab Republic in 2003 to that in 2008?
Your response must be concise. 0.65. What is the ratio of the Amount (in $) in Croatia in 2003 to that in 2009?
Your response must be concise. 0.71. What is the ratio of the Amount (in $) of Jamaica in 2003 to that in 2009?
Give a very brief answer. 0.5. What is the ratio of the Amount (in $) in Malta in 2003 to that in 2009?
Ensure brevity in your answer.  1.7. What is the ratio of the Amount (in $) in Syrian Arab Republic in 2003 to that in 2009?
Your answer should be compact. 0.53. What is the ratio of the Amount (in $) in Croatia in 2004 to that in 2005?
Give a very brief answer. 0.94. What is the ratio of the Amount (in $) of Jamaica in 2004 to that in 2005?
Make the answer very short. 0.91. What is the ratio of the Amount (in $) of Malta in 2004 to that in 2005?
Provide a short and direct response. 0.96. What is the ratio of the Amount (in $) of Syrian Arab Republic in 2004 to that in 2005?
Ensure brevity in your answer.  0.96. What is the ratio of the Amount (in $) in Croatia in 2004 to that in 2006?
Your response must be concise. 0.87. What is the ratio of the Amount (in $) of Jamaica in 2004 to that in 2006?
Provide a succinct answer. 0.79. What is the ratio of the Amount (in $) in Malta in 2004 to that in 2006?
Offer a terse response. 0.9. What is the ratio of the Amount (in $) in Syrian Arab Republic in 2004 to that in 2006?
Ensure brevity in your answer.  0.79. What is the ratio of the Amount (in $) of Croatia in 2004 to that in 2007?
Give a very brief answer. 0.77. What is the ratio of the Amount (in $) of Jamaica in 2004 to that in 2007?
Provide a short and direct response. 0.68. What is the ratio of the Amount (in $) of Malta in 2004 to that in 2007?
Your answer should be compact. 0.82. What is the ratio of the Amount (in $) in Syrian Arab Republic in 2004 to that in 2007?
Keep it short and to the point. 0.75. What is the ratio of the Amount (in $) of Croatia in 2004 to that in 2008?
Your answer should be compact. 0.73. What is the ratio of the Amount (in $) of Jamaica in 2004 to that in 2008?
Ensure brevity in your answer.  0.62. What is the ratio of the Amount (in $) in Malta in 2004 to that in 2008?
Give a very brief answer. 1.81. What is the ratio of the Amount (in $) in Syrian Arab Republic in 2004 to that in 2008?
Ensure brevity in your answer.  0.7. What is the ratio of the Amount (in $) in Croatia in 2004 to that in 2009?
Provide a succinct answer. 0.77. What is the ratio of the Amount (in $) in Jamaica in 2004 to that in 2009?
Offer a terse response. 0.56. What is the ratio of the Amount (in $) of Malta in 2004 to that in 2009?
Offer a very short reply. 1.81. What is the ratio of the Amount (in $) in Syrian Arab Republic in 2004 to that in 2009?
Ensure brevity in your answer.  0.57. What is the ratio of the Amount (in $) of Croatia in 2005 to that in 2006?
Offer a very short reply. 0.92. What is the ratio of the Amount (in $) of Jamaica in 2005 to that in 2006?
Your response must be concise. 0.87. What is the ratio of the Amount (in $) in Malta in 2005 to that in 2006?
Provide a short and direct response. 0.94. What is the ratio of the Amount (in $) in Syrian Arab Republic in 2005 to that in 2006?
Your answer should be very brief. 0.82. What is the ratio of the Amount (in $) of Croatia in 2005 to that in 2007?
Keep it short and to the point. 0.82. What is the ratio of the Amount (in $) of Jamaica in 2005 to that in 2007?
Provide a short and direct response. 0.75. What is the ratio of the Amount (in $) of Malta in 2005 to that in 2007?
Your response must be concise. 0.86. What is the ratio of the Amount (in $) of Syrian Arab Republic in 2005 to that in 2007?
Offer a terse response. 0.78. What is the ratio of the Amount (in $) in Croatia in 2005 to that in 2008?
Keep it short and to the point. 0.78. What is the ratio of the Amount (in $) in Jamaica in 2005 to that in 2008?
Make the answer very short. 0.68. What is the ratio of the Amount (in $) of Malta in 2005 to that in 2008?
Provide a succinct answer. 1.89. What is the ratio of the Amount (in $) of Syrian Arab Republic in 2005 to that in 2008?
Give a very brief answer. 0.73. What is the ratio of the Amount (in $) in Croatia in 2005 to that in 2009?
Provide a succinct answer. 0.82. What is the ratio of the Amount (in $) in Jamaica in 2005 to that in 2009?
Make the answer very short. 0.62. What is the ratio of the Amount (in $) in Malta in 2005 to that in 2009?
Offer a terse response. 1.89. What is the ratio of the Amount (in $) in Syrian Arab Republic in 2005 to that in 2009?
Ensure brevity in your answer.  0.59. What is the ratio of the Amount (in $) of Croatia in 2006 to that in 2007?
Ensure brevity in your answer.  0.89. What is the ratio of the Amount (in $) in Jamaica in 2006 to that in 2007?
Offer a terse response. 0.87. What is the ratio of the Amount (in $) in Malta in 2006 to that in 2007?
Give a very brief answer. 0.91. What is the ratio of the Amount (in $) in Syrian Arab Republic in 2006 to that in 2007?
Ensure brevity in your answer.  0.95. What is the ratio of the Amount (in $) of Croatia in 2006 to that in 2008?
Offer a very short reply. 0.84. What is the ratio of the Amount (in $) in Jamaica in 2006 to that in 2008?
Keep it short and to the point. 0.78. What is the ratio of the Amount (in $) in Malta in 2006 to that in 2008?
Offer a very short reply. 2.01. What is the ratio of the Amount (in $) in Syrian Arab Republic in 2006 to that in 2008?
Provide a succinct answer. 0.89. What is the ratio of the Amount (in $) of Croatia in 2006 to that in 2009?
Keep it short and to the point. 0.88. What is the ratio of the Amount (in $) of Jamaica in 2006 to that in 2009?
Your answer should be compact. 0.72. What is the ratio of the Amount (in $) in Malta in 2006 to that in 2009?
Ensure brevity in your answer.  2.02. What is the ratio of the Amount (in $) in Syrian Arab Republic in 2006 to that in 2009?
Give a very brief answer. 0.72. What is the ratio of the Amount (in $) in Croatia in 2007 to that in 2008?
Keep it short and to the point. 0.94. What is the ratio of the Amount (in $) in Jamaica in 2007 to that in 2008?
Your answer should be very brief. 0.9. What is the ratio of the Amount (in $) in Malta in 2007 to that in 2008?
Provide a short and direct response. 2.2. What is the ratio of the Amount (in $) of Syrian Arab Republic in 2007 to that in 2008?
Make the answer very short. 0.93. What is the ratio of the Amount (in $) in Jamaica in 2007 to that in 2009?
Offer a very short reply. 0.83. What is the ratio of the Amount (in $) of Malta in 2007 to that in 2009?
Offer a terse response. 2.21. What is the ratio of the Amount (in $) of Syrian Arab Republic in 2007 to that in 2009?
Offer a very short reply. 0.76. What is the ratio of the Amount (in $) in Croatia in 2008 to that in 2009?
Provide a short and direct response. 1.05. What is the ratio of the Amount (in $) of Jamaica in 2008 to that in 2009?
Provide a succinct answer. 0.91. What is the ratio of the Amount (in $) of Malta in 2008 to that in 2009?
Your answer should be very brief. 1. What is the ratio of the Amount (in $) in Syrian Arab Republic in 2008 to that in 2009?
Provide a short and direct response. 0.82. What is the difference between the highest and the second highest Amount (in $) in Croatia?
Keep it short and to the point. 6.06e+09. What is the difference between the highest and the second highest Amount (in $) of Jamaica?
Keep it short and to the point. 2.99e+1. What is the difference between the highest and the second highest Amount (in $) of Malta?
Your answer should be compact. 4.26e+08. What is the difference between the highest and the second highest Amount (in $) in Syrian Arab Republic?
Your answer should be very brief. 1.10e+11. What is the difference between the highest and the lowest Amount (in $) of Croatia?
Ensure brevity in your answer.  3.87e+1. What is the difference between the highest and the lowest Amount (in $) of Jamaica?
Offer a very short reply. 1.73e+11. What is the difference between the highest and the lowest Amount (in $) of Malta?
Provide a succinct answer. 2.70e+09. What is the difference between the highest and the lowest Amount (in $) in Syrian Arab Republic?
Provide a succinct answer. 2.80e+11. 